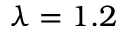<formula> <loc_0><loc_0><loc_500><loc_500>\lambda = 1 . 2</formula> 